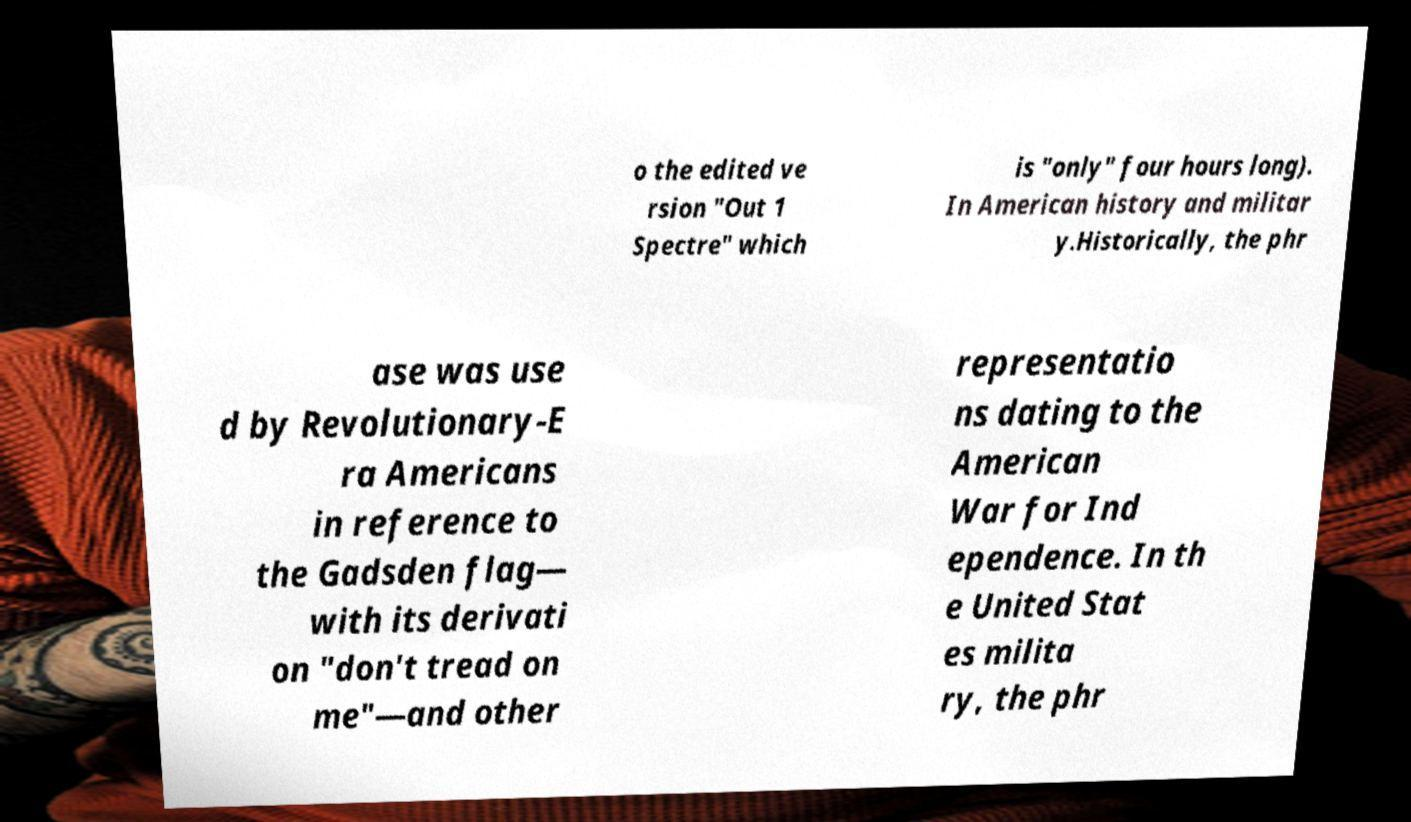Could you assist in decoding the text presented in this image and type it out clearly? o the edited ve rsion "Out 1 Spectre" which is "only" four hours long). In American history and militar y.Historically, the phr ase was use d by Revolutionary-E ra Americans in reference to the Gadsden flag— with its derivati on "don't tread on me"—and other representatio ns dating to the American War for Ind ependence. In th e United Stat es milita ry, the phr 